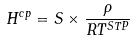Convert formula to latex. <formula><loc_0><loc_0><loc_500><loc_500>H ^ { c p } = S \times \frac { \rho } { R T ^ { S T P } }</formula> 